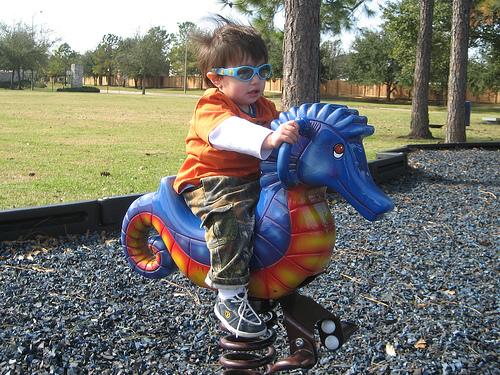<image>
Is the boy on the toy seahorse? Yes. Looking at the image, I can see the boy is positioned on top of the toy seahorse, with the toy seahorse providing support. Is the toddler on the seahorse? Yes. Looking at the image, I can see the toddler is positioned on top of the seahorse, with the seahorse providing support. Is the kid behind the seahorse? No. The kid is not behind the seahorse. From this viewpoint, the kid appears to be positioned elsewhere in the scene. 